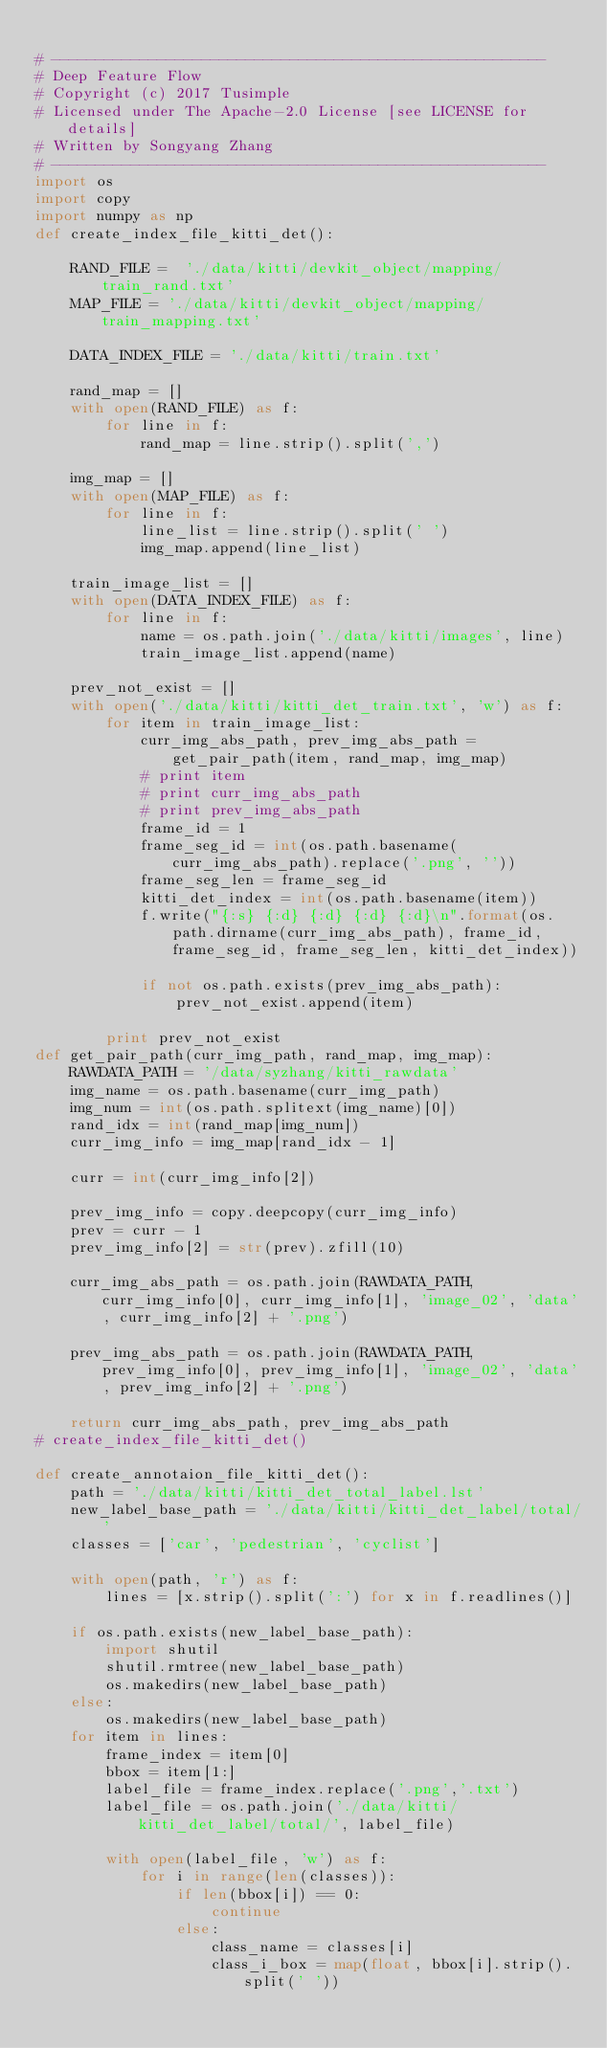Convert code to text. <code><loc_0><loc_0><loc_500><loc_500><_Python_>
# --------------------------------------------------------
# Deep Feature Flow
# Copyright (c) 2017 Tusimple
# Licensed under The Apache-2.0 License [see LICENSE for details]
# Written by Songyang Zhang
# --------------------------------------------------------
import os
import copy
import numpy as np
def create_index_file_kitti_det():

    RAND_FILE =  './data/kitti/devkit_object/mapping/train_rand.txt'
    MAP_FILE = './data/kitti/devkit_object/mapping/train_mapping.txt'

    DATA_INDEX_FILE = './data/kitti/train.txt'

    rand_map = []
    with open(RAND_FILE) as f:
        for line in f:
            rand_map = line.strip().split(',')

    img_map = []
    with open(MAP_FILE) as f:
        for line in f:
            line_list = line.strip().split(' ')
            img_map.append(line_list)

    train_image_list = []
    with open(DATA_INDEX_FILE) as f:
        for line in f:
            name = os.path.join('./data/kitti/images', line)
            train_image_list.append(name)

    prev_not_exist = []
    with open('./data/kitti/kitti_det_train.txt', 'w') as f:
        for item in train_image_list:
            curr_img_abs_path, prev_img_abs_path = get_pair_path(item, rand_map, img_map)
            # print item
            # print curr_img_abs_path
            # print prev_img_abs_path
            frame_id = 1
            frame_seg_id = int(os.path.basename(curr_img_abs_path).replace('.png', ''))
            frame_seg_len = frame_seg_id
            kitti_det_index = int(os.path.basename(item))
            f.write("{:s} {:d} {:d} {:d} {:d}\n".format(os.path.dirname(curr_img_abs_path), frame_id, frame_seg_id, frame_seg_len, kitti_det_index))

            if not os.path.exists(prev_img_abs_path):
                prev_not_exist.append(item)

        print prev_not_exist
def get_pair_path(curr_img_path, rand_map, img_map):
    RAWDATA_PATH = '/data/syzhang/kitti_rawdata'
    img_name = os.path.basename(curr_img_path)
    img_num = int(os.path.splitext(img_name)[0])
    rand_idx = int(rand_map[img_num])
    curr_img_info = img_map[rand_idx - 1]

    curr = int(curr_img_info[2])

    prev_img_info = copy.deepcopy(curr_img_info)
    prev = curr - 1
    prev_img_info[2] = str(prev).zfill(10)

    curr_img_abs_path = os.path.join(RAWDATA_PATH, curr_img_info[0], curr_img_info[1], 'image_02', 'data', curr_img_info[2] + '.png')

    prev_img_abs_path = os.path.join(RAWDATA_PATH, prev_img_info[0], prev_img_info[1], 'image_02', 'data', prev_img_info[2] + '.png')

    return curr_img_abs_path, prev_img_abs_path
# create_index_file_kitti_det()

def create_annotaion_file_kitti_det():
    path = './data/kitti/kitti_det_total_label.lst'
    new_label_base_path = './data/kitti/kitti_det_label/total/'
    classes = ['car', 'pedestrian', 'cyclist']

    with open(path, 'r') as f:
        lines = [x.strip().split(':') for x in f.readlines()]

    if os.path.exists(new_label_base_path):
        import shutil
        shutil.rmtree(new_label_base_path)
        os.makedirs(new_label_base_path)
    else:
        os.makedirs(new_label_base_path)
    for item in lines:
        frame_index = item[0]
        bbox = item[1:]
        label_file = frame_index.replace('.png','.txt')
        label_file = os.path.join('./data/kitti/kitti_det_label/total/', label_file)

        with open(label_file, 'w') as f:
            for i in range(len(classes)):
                if len(bbox[i]) == 0:
                    continue
                else:
                    class_name = classes[i]
                    class_i_box = map(float, bbox[i].strip().split(' '))</code> 